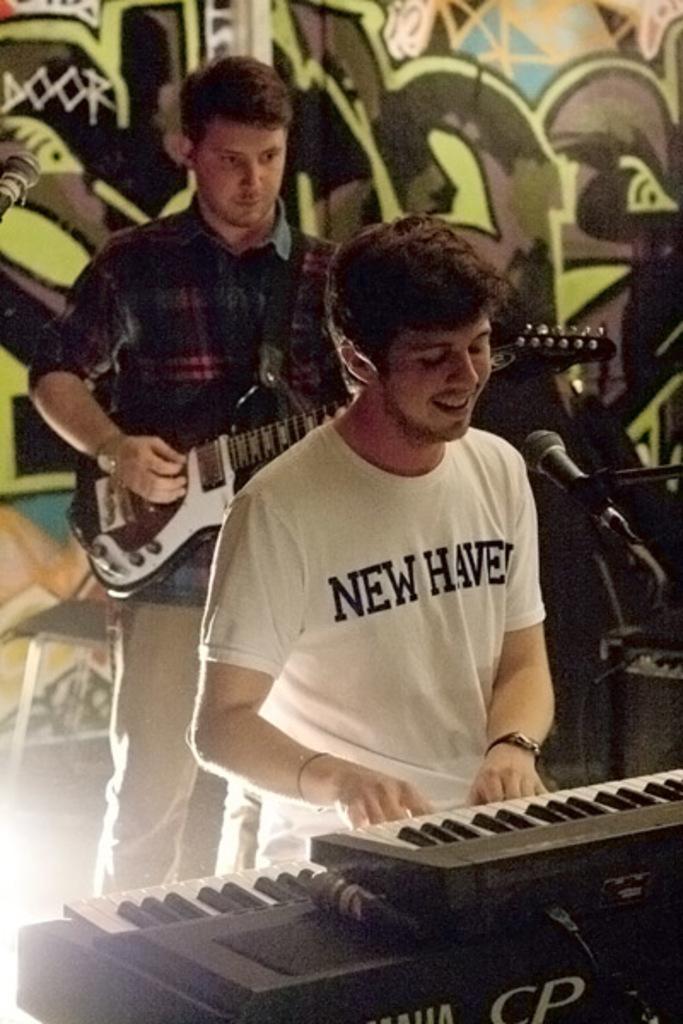In one or two sentences, can you explain what this image depicts? in the picture there are two persons one person standing and playing guitar another person sitting and playing piano with a micro phone in front of him. 